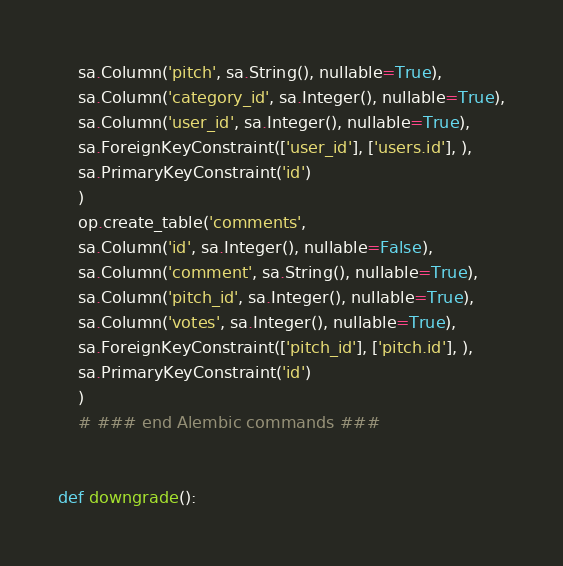Convert code to text. <code><loc_0><loc_0><loc_500><loc_500><_Python_>    sa.Column('pitch', sa.String(), nullable=True),
    sa.Column('category_id', sa.Integer(), nullable=True),
    sa.Column('user_id', sa.Integer(), nullable=True),
    sa.ForeignKeyConstraint(['user_id'], ['users.id'], ),
    sa.PrimaryKeyConstraint('id')
    )
    op.create_table('comments',
    sa.Column('id', sa.Integer(), nullable=False),
    sa.Column('comment', sa.String(), nullable=True),
    sa.Column('pitch_id', sa.Integer(), nullable=True),
    sa.Column('votes', sa.Integer(), nullable=True),
    sa.ForeignKeyConstraint(['pitch_id'], ['pitch.id'], ),
    sa.PrimaryKeyConstraint('id')
    )
    # ### end Alembic commands ###


def downgrade():</code> 